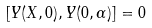Convert formula to latex. <formula><loc_0><loc_0><loc_500><loc_500>[ Y ( X , 0 ) , Y ( 0 , \alpha ) ] = 0</formula> 